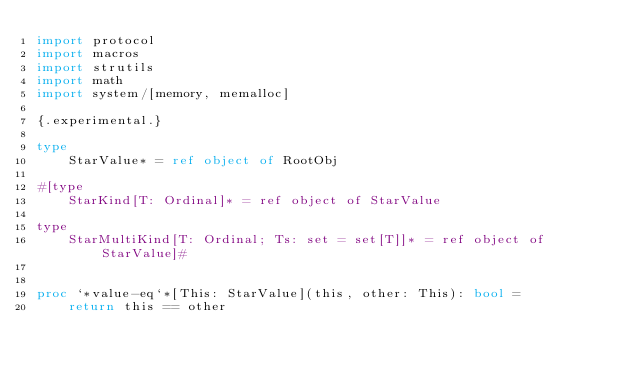<code> <loc_0><loc_0><loc_500><loc_500><_Nim_>import protocol
import macros
import strutils
import math
import system/[memory, memalloc]

{.experimental.}

type
    StarValue* = ref object of RootObj

#[type
    StarKind[T: Ordinal]* = ref object of StarValue

type
    StarMultiKind[T: Ordinal; Ts: set = set[T]]* = ref object of StarValue]#


proc `*value-eq`*[This: StarValue](this, other: This): bool =
    return this == other
</code> 